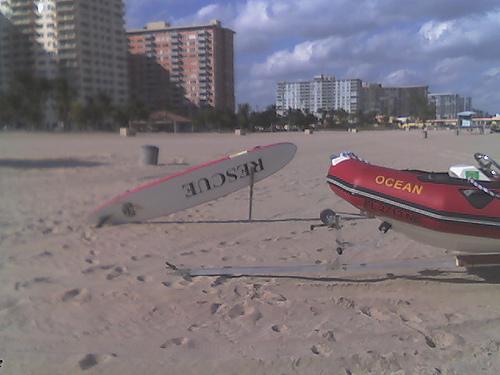What color is the boat?
Give a very brief answer. Red. What does the boat say?
Keep it brief. Ocean. What does the board say?
Write a very short answer. Rescue. 